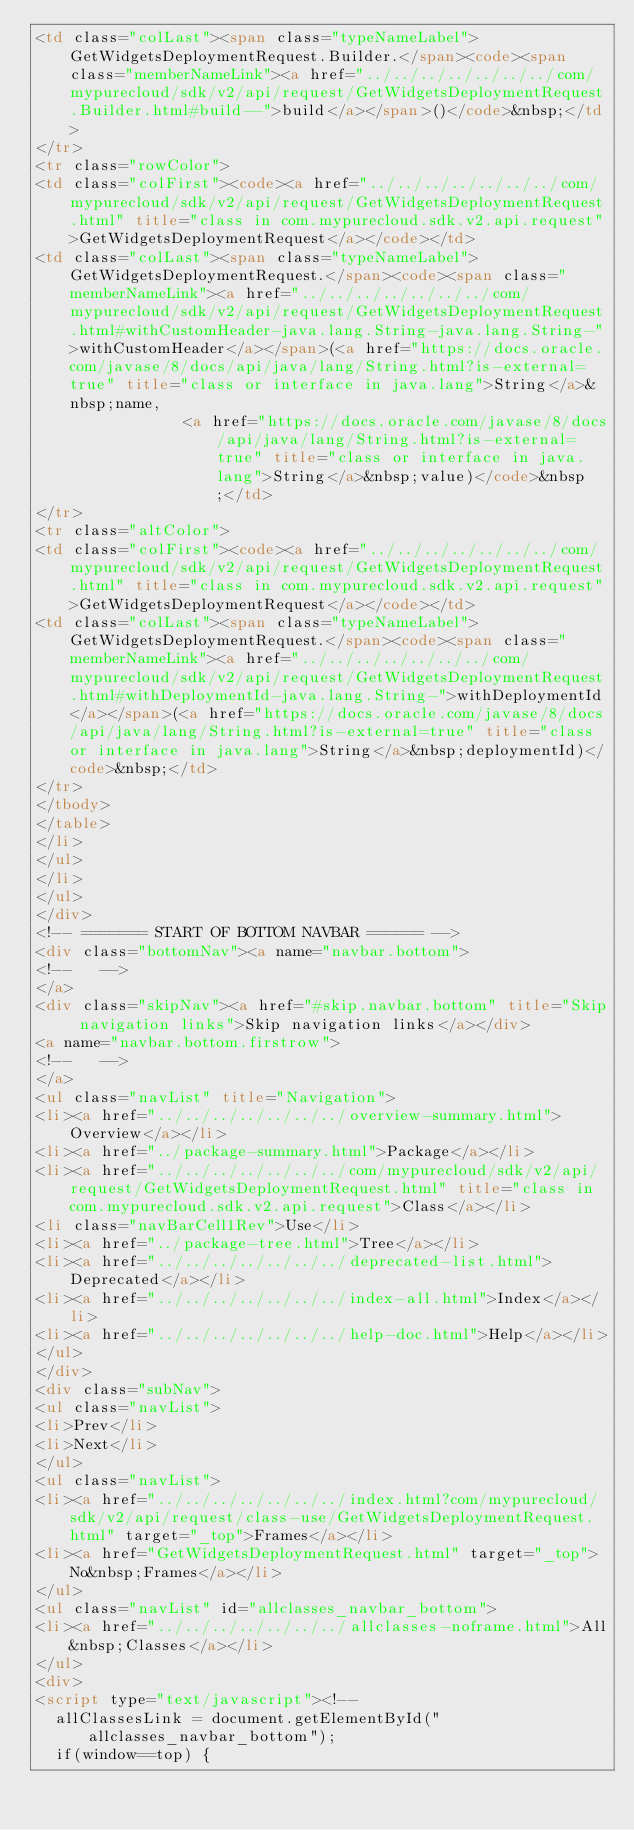<code> <loc_0><loc_0><loc_500><loc_500><_HTML_><td class="colLast"><span class="typeNameLabel">GetWidgetsDeploymentRequest.Builder.</span><code><span class="memberNameLink"><a href="../../../../../../../com/mypurecloud/sdk/v2/api/request/GetWidgetsDeploymentRequest.Builder.html#build--">build</a></span>()</code>&nbsp;</td>
</tr>
<tr class="rowColor">
<td class="colFirst"><code><a href="../../../../../../../com/mypurecloud/sdk/v2/api/request/GetWidgetsDeploymentRequest.html" title="class in com.mypurecloud.sdk.v2.api.request">GetWidgetsDeploymentRequest</a></code></td>
<td class="colLast"><span class="typeNameLabel">GetWidgetsDeploymentRequest.</span><code><span class="memberNameLink"><a href="../../../../../../../com/mypurecloud/sdk/v2/api/request/GetWidgetsDeploymentRequest.html#withCustomHeader-java.lang.String-java.lang.String-">withCustomHeader</a></span>(<a href="https://docs.oracle.com/javase/8/docs/api/java/lang/String.html?is-external=true" title="class or interface in java.lang">String</a>&nbsp;name,
                <a href="https://docs.oracle.com/javase/8/docs/api/java/lang/String.html?is-external=true" title="class or interface in java.lang">String</a>&nbsp;value)</code>&nbsp;</td>
</tr>
<tr class="altColor">
<td class="colFirst"><code><a href="../../../../../../../com/mypurecloud/sdk/v2/api/request/GetWidgetsDeploymentRequest.html" title="class in com.mypurecloud.sdk.v2.api.request">GetWidgetsDeploymentRequest</a></code></td>
<td class="colLast"><span class="typeNameLabel">GetWidgetsDeploymentRequest.</span><code><span class="memberNameLink"><a href="../../../../../../../com/mypurecloud/sdk/v2/api/request/GetWidgetsDeploymentRequest.html#withDeploymentId-java.lang.String-">withDeploymentId</a></span>(<a href="https://docs.oracle.com/javase/8/docs/api/java/lang/String.html?is-external=true" title="class or interface in java.lang">String</a>&nbsp;deploymentId)</code>&nbsp;</td>
</tr>
</tbody>
</table>
</li>
</ul>
</li>
</ul>
</div>
<!-- ======= START OF BOTTOM NAVBAR ====== -->
<div class="bottomNav"><a name="navbar.bottom">
<!--   -->
</a>
<div class="skipNav"><a href="#skip.navbar.bottom" title="Skip navigation links">Skip navigation links</a></div>
<a name="navbar.bottom.firstrow">
<!--   -->
</a>
<ul class="navList" title="Navigation">
<li><a href="../../../../../../../overview-summary.html">Overview</a></li>
<li><a href="../package-summary.html">Package</a></li>
<li><a href="../../../../../../../com/mypurecloud/sdk/v2/api/request/GetWidgetsDeploymentRequest.html" title="class in com.mypurecloud.sdk.v2.api.request">Class</a></li>
<li class="navBarCell1Rev">Use</li>
<li><a href="../package-tree.html">Tree</a></li>
<li><a href="../../../../../../../deprecated-list.html">Deprecated</a></li>
<li><a href="../../../../../../../index-all.html">Index</a></li>
<li><a href="../../../../../../../help-doc.html">Help</a></li>
</ul>
</div>
<div class="subNav">
<ul class="navList">
<li>Prev</li>
<li>Next</li>
</ul>
<ul class="navList">
<li><a href="../../../../../../../index.html?com/mypurecloud/sdk/v2/api/request/class-use/GetWidgetsDeploymentRequest.html" target="_top">Frames</a></li>
<li><a href="GetWidgetsDeploymentRequest.html" target="_top">No&nbsp;Frames</a></li>
</ul>
<ul class="navList" id="allclasses_navbar_bottom">
<li><a href="../../../../../../../allclasses-noframe.html">All&nbsp;Classes</a></li>
</ul>
<div>
<script type="text/javascript"><!--
  allClassesLink = document.getElementById("allclasses_navbar_bottom");
  if(window==top) {</code> 